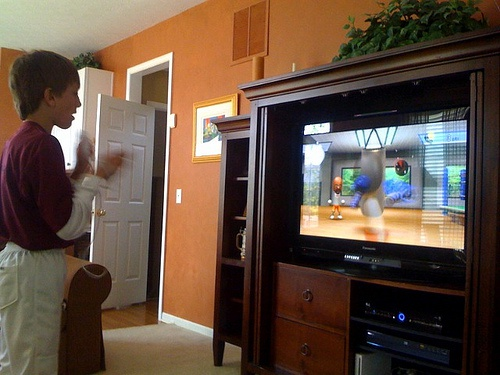Describe the objects in this image and their specific colors. I can see tv in beige, black, white, darkgray, and tan tones, people in beige, black, gray, and maroon tones, potted plant in beige, black, olive, brown, and darkgreen tones, chair in beige, black, maroon, and gray tones, and remote in beige, darkgray, lightgray, and gray tones in this image. 